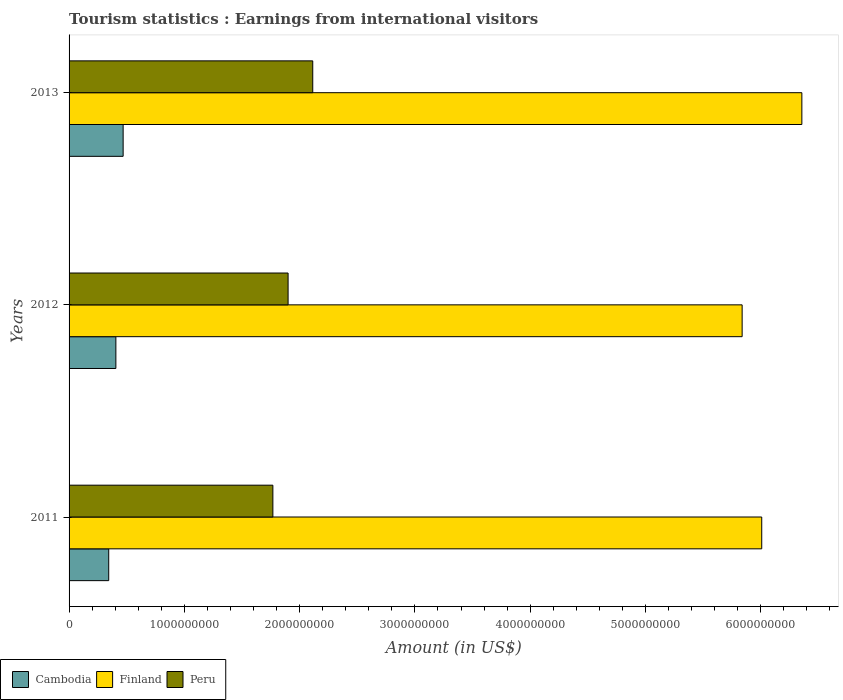Are the number of bars per tick equal to the number of legend labels?
Offer a terse response. Yes. How many bars are there on the 2nd tick from the top?
Give a very brief answer. 3. How many bars are there on the 3rd tick from the bottom?
Provide a short and direct response. 3. What is the label of the 1st group of bars from the top?
Your answer should be compact. 2013. What is the earnings from international visitors in Cambodia in 2013?
Give a very brief answer. 4.69e+08. Across all years, what is the maximum earnings from international visitors in Peru?
Your response must be concise. 2.11e+09. Across all years, what is the minimum earnings from international visitors in Peru?
Give a very brief answer. 1.77e+09. In which year was the earnings from international visitors in Cambodia maximum?
Your answer should be very brief. 2013. What is the total earnings from international visitors in Finland in the graph?
Make the answer very short. 1.82e+1. What is the difference between the earnings from international visitors in Peru in 2012 and that in 2013?
Your answer should be compact. -2.14e+08. What is the difference between the earnings from international visitors in Finland in 2011 and the earnings from international visitors in Cambodia in 2012?
Ensure brevity in your answer.  5.60e+09. What is the average earnings from international visitors in Cambodia per year?
Your response must be concise. 4.06e+08. In the year 2011, what is the difference between the earnings from international visitors in Finland and earnings from international visitors in Cambodia?
Ensure brevity in your answer.  5.66e+09. What is the ratio of the earnings from international visitors in Peru in 2011 to that in 2012?
Provide a short and direct response. 0.93. What is the difference between the highest and the second highest earnings from international visitors in Cambodia?
Your response must be concise. 6.30e+07. What is the difference between the highest and the lowest earnings from international visitors in Peru?
Your response must be concise. 3.46e+08. Is the sum of the earnings from international visitors in Peru in 2011 and 2013 greater than the maximum earnings from international visitors in Finland across all years?
Ensure brevity in your answer.  No. What does the 3rd bar from the top in 2012 represents?
Ensure brevity in your answer.  Cambodia. How many bars are there?
Offer a terse response. 9. What is the difference between two consecutive major ticks on the X-axis?
Keep it short and to the point. 1.00e+09. Where does the legend appear in the graph?
Ensure brevity in your answer.  Bottom left. How many legend labels are there?
Make the answer very short. 3. How are the legend labels stacked?
Offer a very short reply. Horizontal. What is the title of the graph?
Offer a terse response. Tourism statistics : Earnings from international visitors. Does "Low income" appear as one of the legend labels in the graph?
Offer a very short reply. No. What is the Amount (in US$) in Cambodia in 2011?
Offer a very short reply. 3.44e+08. What is the Amount (in US$) of Finland in 2011?
Your answer should be compact. 6.01e+09. What is the Amount (in US$) of Peru in 2011?
Offer a terse response. 1.77e+09. What is the Amount (in US$) of Cambodia in 2012?
Your response must be concise. 4.06e+08. What is the Amount (in US$) of Finland in 2012?
Give a very brief answer. 5.84e+09. What is the Amount (in US$) of Peru in 2012?
Offer a very short reply. 1.90e+09. What is the Amount (in US$) in Cambodia in 2013?
Ensure brevity in your answer.  4.69e+08. What is the Amount (in US$) in Finland in 2013?
Provide a succinct answer. 6.36e+09. What is the Amount (in US$) in Peru in 2013?
Your response must be concise. 2.11e+09. Across all years, what is the maximum Amount (in US$) in Cambodia?
Give a very brief answer. 4.69e+08. Across all years, what is the maximum Amount (in US$) of Finland?
Your answer should be compact. 6.36e+09. Across all years, what is the maximum Amount (in US$) of Peru?
Give a very brief answer. 2.11e+09. Across all years, what is the minimum Amount (in US$) of Cambodia?
Your answer should be compact. 3.44e+08. Across all years, what is the minimum Amount (in US$) of Finland?
Give a very brief answer. 5.84e+09. Across all years, what is the minimum Amount (in US$) of Peru?
Keep it short and to the point. 1.77e+09. What is the total Amount (in US$) of Cambodia in the graph?
Provide a succinct answer. 1.22e+09. What is the total Amount (in US$) in Finland in the graph?
Make the answer very short. 1.82e+1. What is the total Amount (in US$) of Peru in the graph?
Give a very brief answer. 5.78e+09. What is the difference between the Amount (in US$) of Cambodia in 2011 and that in 2012?
Provide a short and direct response. -6.20e+07. What is the difference between the Amount (in US$) in Finland in 2011 and that in 2012?
Your response must be concise. 1.70e+08. What is the difference between the Amount (in US$) in Peru in 2011 and that in 2012?
Ensure brevity in your answer.  -1.32e+08. What is the difference between the Amount (in US$) in Cambodia in 2011 and that in 2013?
Give a very brief answer. -1.25e+08. What is the difference between the Amount (in US$) of Finland in 2011 and that in 2013?
Offer a terse response. -3.48e+08. What is the difference between the Amount (in US$) of Peru in 2011 and that in 2013?
Make the answer very short. -3.46e+08. What is the difference between the Amount (in US$) of Cambodia in 2012 and that in 2013?
Make the answer very short. -6.30e+07. What is the difference between the Amount (in US$) of Finland in 2012 and that in 2013?
Your answer should be very brief. -5.18e+08. What is the difference between the Amount (in US$) of Peru in 2012 and that in 2013?
Your answer should be very brief. -2.14e+08. What is the difference between the Amount (in US$) in Cambodia in 2011 and the Amount (in US$) in Finland in 2012?
Keep it short and to the point. -5.50e+09. What is the difference between the Amount (in US$) in Cambodia in 2011 and the Amount (in US$) in Peru in 2012?
Provide a succinct answer. -1.56e+09. What is the difference between the Amount (in US$) of Finland in 2011 and the Amount (in US$) of Peru in 2012?
Provide a succinct answer. 4.11e+09. What is the difference between the Amount (in US$) in Cambodia in 2011 and the Amount (in US$) in Finland in 2013?
Make the answer very short. -6.01e+09. What is the difference between the Amount (in US$) of Cambodia in 2011 and the Amount (in US$) of Peru in 2013?
Offer a very short reply. -1.77e+09. What is the difference between the Amount (in US$) in Finland in 2011 and the Amount (in US$) in Peru in 2013?
Your answer should be very brief. 3.90e+09. What is the difference between the Amount (in US$) of Cambodia in 2012 and the Amount (in US$) of Finland in 2013?
Your answer should be compact. -5.95e+09. What is the difference between the Amount (in US$) of Cambodia in 2012 and the Amount (in US$) of Peru in 2013?
Ensure brevity in your answer.  -1.71e+09. What is the difference between the Amount (in US$) in Finland in 2012 and the Amount (in US$) in Peru in 2013?
Offer a terse response. 3.72e+09. What is the average Amount (in US$) of Cambodia per year?
Your response must be concise. 4.06e+08. What is the average Amount (in US$) in Finland per year?
Make the answer very short. 6.07e+09. What is the average Amount (in US$) of Peru per year?
Your response must be concise. 1.93e+09. In the year 2011, what is the difference between the Amount (in US$) in Cambodia and Amount (in US$) in Finland?
Offer a terse response. -5.66e+09. In the year 2011, what is the difference between the Amount (in US$) of Cambodia and Amount (in US$) of Peru?
Make the answer very short. -1.42e+09. In the year 2011, what is the difference between the Amount (in US$) of Finland and Amount (in US$) of Peru?
Provide a succinct answer. 4.24e+09. In the year 2012, what is the difference between the Amount (in US$) in Cambodia and Amount (in US$) in Finland?
Provide a short and direct response. -5.43e+09. In the year 2012, what is the difference between the Amount (in US$) in Cambodia and Amount (in US$) in Peru?
Provide a succinct answer. -1.49e+09. In the year 2012, what is the difference between the Amount (in US$) in Finland and Amount (in US$) in Peru?
Your response must be concise. 3.94e+09. In the year 2013, what is the difference between the Amount (in US$) of Cambodia and Amount (in US$) of Finland?
Keep it short and to the point. -5.89e+09. In the year 2013, what is the difference between the Amount (in US$) in Cambodia and Amount (in US$) in Peru?
Your response must be concise. -1.64e+09. In the year 2013, what is the difference between the Amount (in US$) in Finland and Amount (in US$) in Peru?
Your answer should be very brief. 4.24e+09. What is the ratio of the Amount (in US$) of Cambodia in 2011 to that in 2012?
Provide a succinct answer. 0.85. What is the ratio of the Amount (in US$) in Finland in 2011 to that in 2012?
Give a very brief answer. 1.03. What is the ratio of the Amount (in US$) of Peru in 2011 to that in 2012?
Offer a terse response. 0.93. What is the ratio of the Amount (in US$) of Cambodia in 2011 to that in 2013?
Your response must be concise. 0.73. What is the ratio of the Amount (in US$) of Finland in 2011 to that in 2013?
Ensure brevity in your answer.  0.95. What is the ratio of the Amount (in US$) of Peru in 2011 to that in 2013?
Provide a succinct answer. 0.84. What is the ratio of the Amount (in US$) of Cambodia in 2012 to that in 2013?
Your answer should be compact. 0.87. What is the ratio of the Amount (in US$) in Finland in 2012 to that in 2013?
Provide a succinct answer. 0.92. What is the ratio of the Amount (in US$) in Peru in 2012 to that in 2013?
Give a very brief answer. 0.9. What is the difference between the highest and the second highest Amount (in US$) of Cambodia?
Provide a short and direct response. 6.30e+07. What is the difference between the highest and the second highest Amount (in US$) of Finland?
Offer a terse response. 3.48e+08. What is the difference between the highest and the second highest Amount (in US$) of Peru?
Your answer should be compact. 2.14e+08. What is the difference between the highest and the lowest Amount (in US$) of Cambodia?
Your answer should be compact. 1.25e+08. What is the difference between the highest and the lowest Amount (in US$) of Finland?
Ensure brevity in your answer.  5.18e+08. What is the difference between the highest and the lowest Amount (in US$) in Peru?
Offer a very short reply. 3.46e+08. 